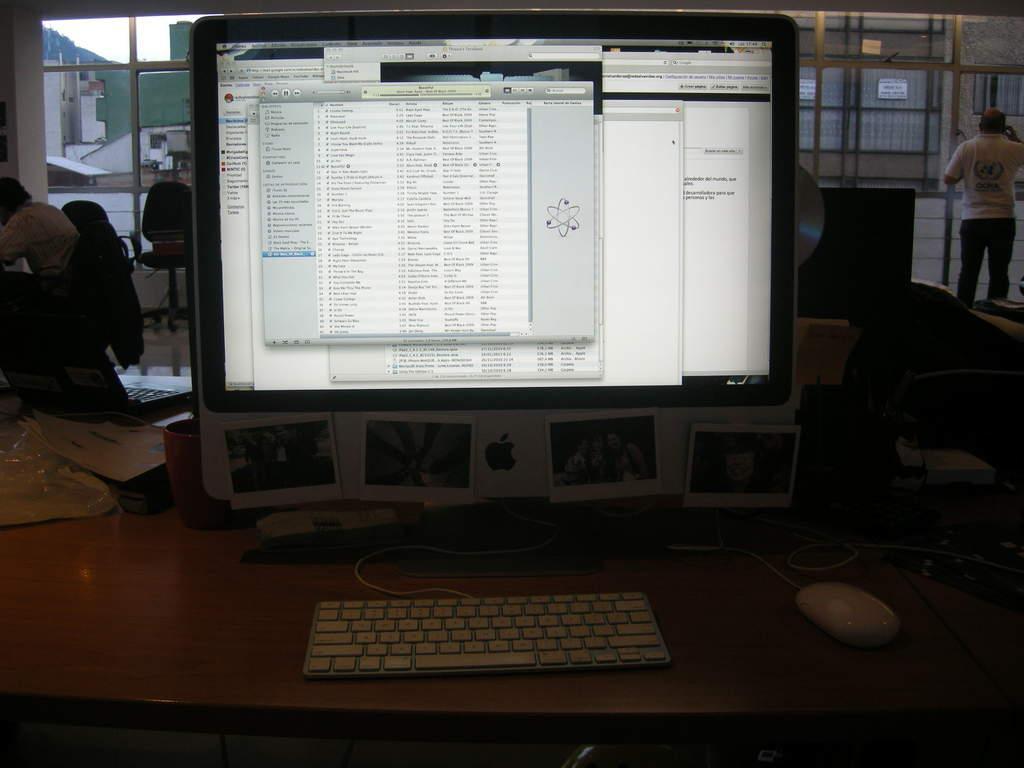Could you give a brief overview of what you see in this image? In this picture, we see a brown table on which monitor, keyboard and mouse are placed. Behind that, the man in white shirt is wearing a backpack. On the right side, the man in the white T-shirt is standing. In front of him, we see windows from which we can see buildings and cars. This picture is clicked in the dark. 